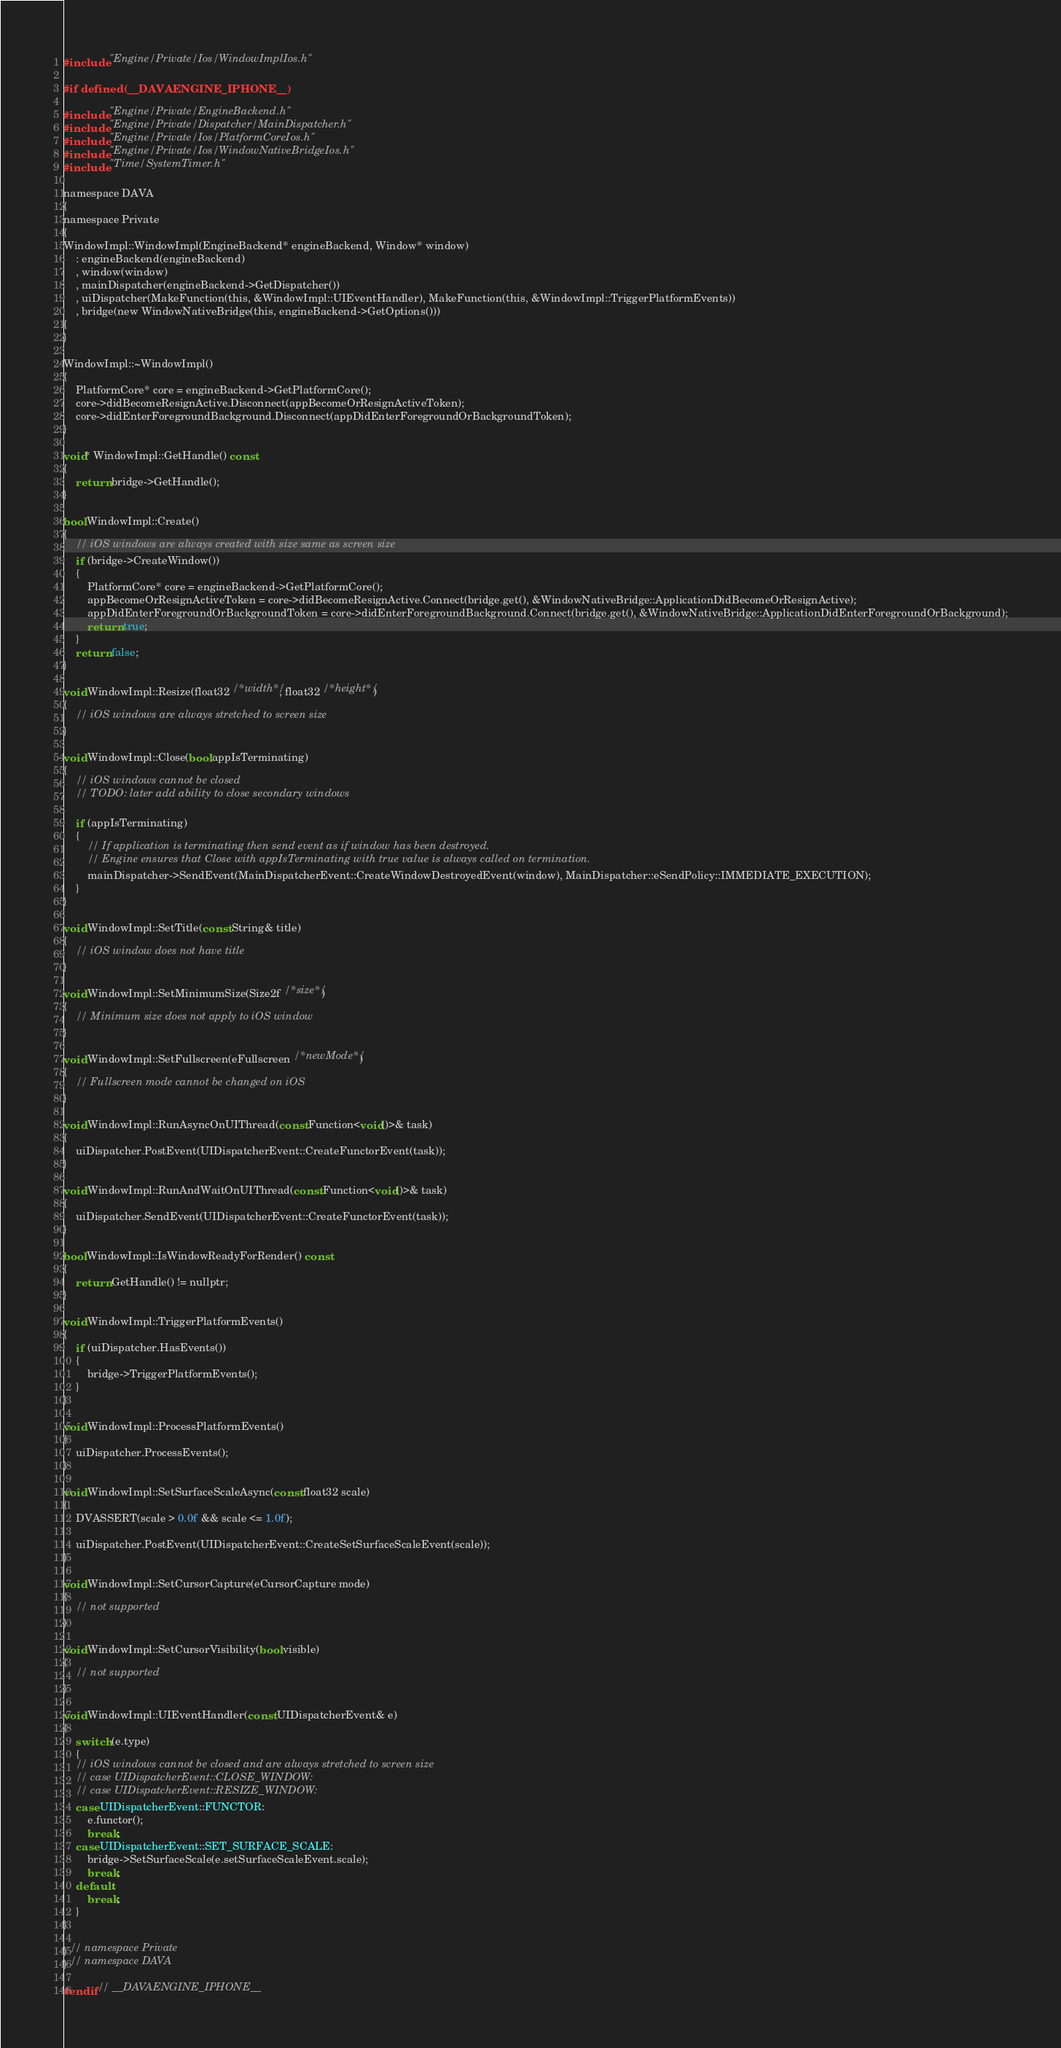<code> <loc_0><loc_0><loc_500><loc_500><_ObjectiveC_>#include "Engine/Private/Ios/WindowImplIos.h"

#if defined(__DAVAENGINE_IPHONE__)

#include "Engine/Private/EngineBackend.h"
#include "Engine/Private/Dispatcher/MainDispatcher.h"
#include "Engine/Private/Ios/PlatformCoreIos.h"
#include "Engine/Private/Ios/WindowNativeBridgeIos.h"
#include "Time/SystemTimer.h"

namespace DAVA
{
namespace Private
{
WindowImpl::WindowImpl(EngineBackend* engineBackend, Window* window)
    : engineBackend(engineBackend)
    , window(window)
    , mainDispatcher(engineBackend->GetDispatcher())
    , uiDispatcher(MakeFunction(this, &WindowImpl::UIEventHandler), MakeFunction(this, &WindowImpl::TriggerPlatformEvents))
    , bridge(new WindowNativeBridge(this, engineBackend->GetOptions()))
{
}

WindowImpl::~WindowImpl()
{
    PlatformCore* core = engineBackend->GetPlatformCore();
    core->didBecomeResignActive.Disconnect(appBecomeOrResignActiveToken);
    core->didEnterForegroundBackground.Disconnect(appDidEnterForegroundOrBackgroundToken);
}

void* WindowImpl::GetHandle() const
{
    return bridge->GetHandle();
}

bool WindowImpl::Create()
{
    // iOS windows are always created with size same as screen size
    if (bridge->CreateWindow())
    {
        PlatformCore* core = engineBackend->GetPlatformCore();
        appBecomeOrResignActiveToken = core->didBecomeResignActive.Connect(bridge.get(), &WindowNativeBridge::ApplicationDidBecomeOrResignActive);
        appDidEnterForegroundOrBackgroundToken = core->didEnterForegroundBackground.Connect(bridge.get(), &WindowNativeBridge::ApplicationDidEnterForegroundOrBackground);
        return true;
    }
    return false;
}

void WindowImpl::Resize(float32 /*width*/, float32 /*height*/)
{
    // iOS windows are always stretched to screen size
}

void WindowImpl::Close(bool appIsTerminating)
{
    // iOS windows cannot be closed
    // TODO: later add ability to close secondary windows

    if (appIsTerminating)
    {
        // If application is terminating then send event as if window has been destroyed.
        // Engine ensures that Close with appIsTerminating with true value is always called on termination.
        mainDispatcher->SendEvent(MainDispatcherEvent::CreateWindowDestroyedEvent(window), MainDispatcher::eSendPolicy::IMMEDIATE_EXECUTION);
    }
}

void WindowImpl::SetTitle(const String& title)
{
    // iOS window does not have title
}

void WindowImpl::SetMinimumSize(Size2f /*size*/)
{
    // Minimum size does not apply to iOS window
}

void WindowImpl::SetFullscreen(eFullscreen /*newMode*/)
{
    // Fullscreen mode cannot be changed on iOS
}

void WindowImpl::RunAsyncOnUIThread(const Function<void()>& task)
{
    uiDispatcher.PostEvent(UIDispatcherEvent::CreateFunctorEvent(task));
}

void WindowImpl::RunAndWaitOnUIThread(const Function<void()>& task)
{
    uiDispatcher.SendEvent(UIDispatcherEvent::CreateFunctorEvent(task));
}

bool WindowImpl::IsWindowReadyForRender() const
{
    return GetHandle() != nullptr;
}

void WindowImpl::TriggerPlatformEvents()
{
    if (uiDispatcher.HasEvents())
    {
        bridge->TriggerPlatformEvents();
    }
}

void WindowImpl::ProcessPlatformEvents()
{
    uiDispatcher.ProcessEvents();
}

void WindowImpl::SetSurfaceScaleAsync(const float32 scale)
{
    DVASSERT(scale > 0.0f && scale <= 1.0f);

    uiDispatcher.PostEvent(UIDispatcherEvent::CreateSetSurfaceScaleEvent(scale));
}

void WindowImpl::SetCursorCapture(eCursorCapture mode)
{
    // not supported
}

void WindowImpl::SetCursorVisibility(bool visible)
{
    // not supported
}

void WindowImpl::UIEventHandler(const UIDispatcherEvent& e)
{
    switch (e.type)
    {
    // iOS windows cannot be closed and are always stretched to screen size
    // case UIDispatcherEvent::CLOSE_WINDOW:
    // case UIDispatcherEvent::RESIZE_WINDOW:
    case UIDispatcherEvent::FUNCTOR:
        e.functor();
        break;
    case UIDispatcherEvent::SET_SURFACE_SCALE:
        bridge->SetSurfaceScale(e.setSurfaceScaleEvent.scale);
        break;
    default:
        break;
    }
}

} // namespace Private
} // namespace DAVA

#endif // __DAVAENGINE_IPHONE__
</code> 